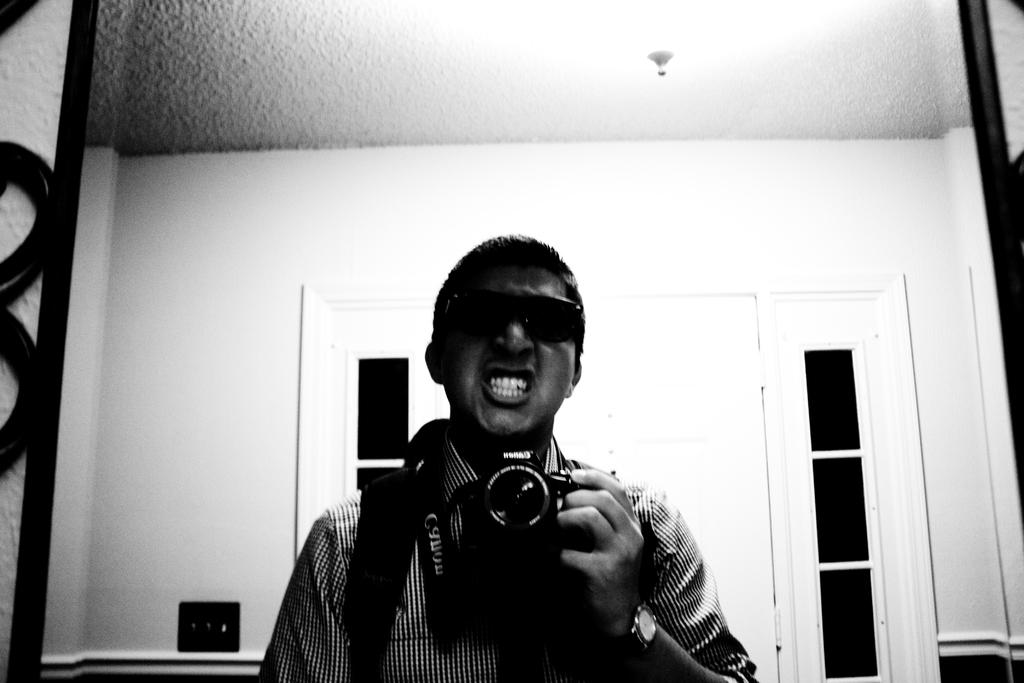What is the person holding in their left hand in the image? The person is holding a camera in their left hand. What can be seen in the background of the image? The person is standing in front of a mirror. What type of flower is present on the person's pets in the image? There are no flowers or pets present in the image. What type of approval is the person seeking in the image? There is no indication in the image that the person is seeking any approval. 